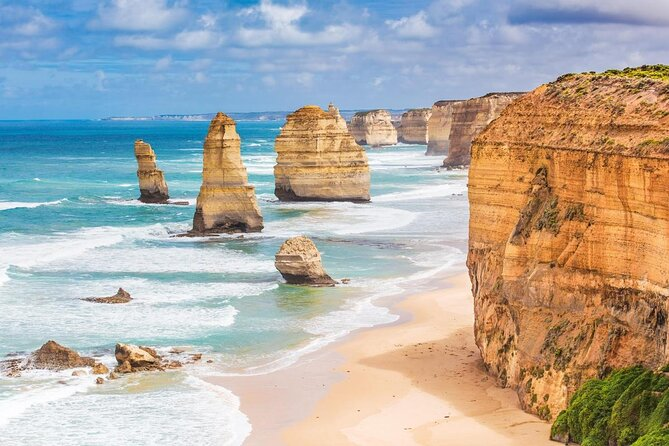What time of day do you think it is in this photo? Based on the lighting and the shadows cast by the limestone stacks, it appears to be late morning or early afternoon. The sunlight is bright but not directly overhead, suggesting that the day is well underway. The vivid blue of the ocean and the defined contours of the clouds further support this observation. 